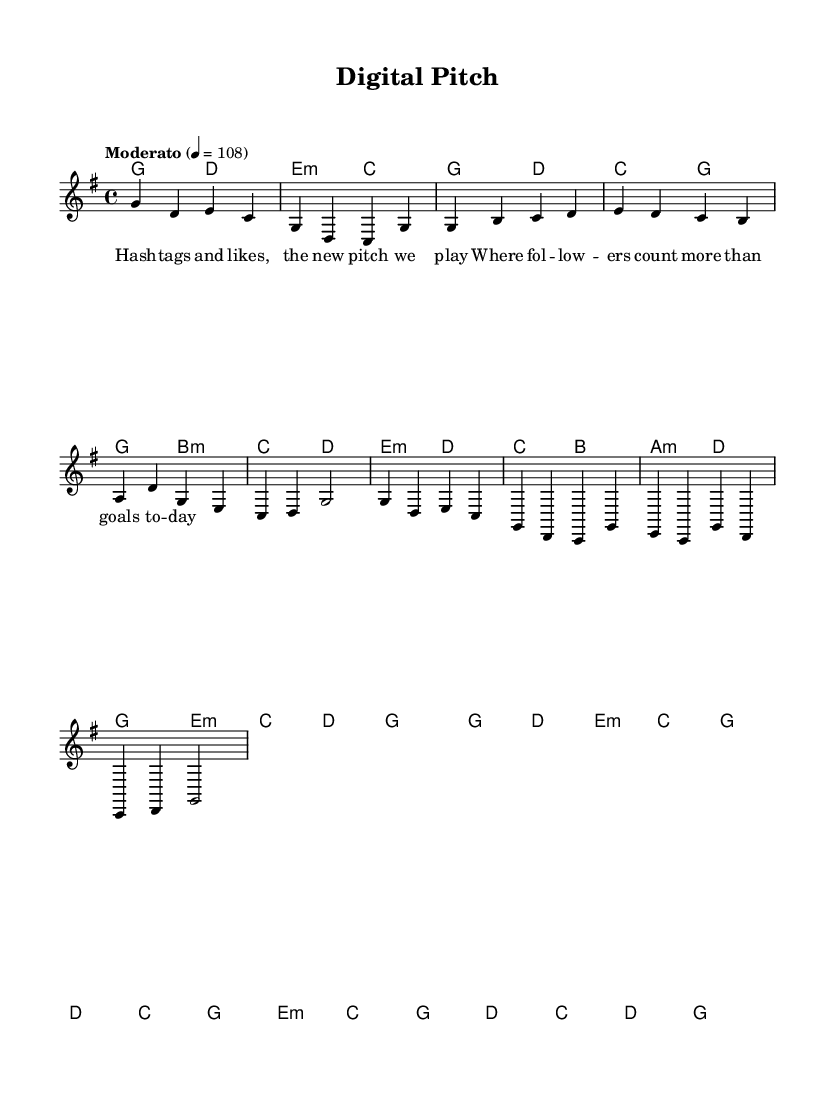What is the key signature of this music? The key signature is indicated at the beginning of the music score, showing one sharp for F sharp. This means the music is in G major.
Answer: G major What is the time signature of this piece? The time signature appears at the start of the score, showing 4 beats per measure, which is common in many music styles, indicating a 4/4 time signature.
Answer: 4/4 What is the tempo marking for this composition? The tempo marking is found in the header section of the score, where it specifies a moderate speed of 108 beats per minute.
Answer: Moderato, 108 How many measures are in the verse section? By counting the individual segments of the verse in the melody and harmonies, there are a total of 8 measures in the verse section.
Answer: 8 Which style does this piece represent? The title and the characteristics of the music, incorporating electronic elements and modern themes, indicate it belongs to the modern folk fusion genre.
Answer: Modern folk fusion What are the primary themes of the lyrics? The lyrics in the verse focus on social media's influence and its impact on how followers and likes have taken precedence over traditional sports achievements.
Answer: Social media's impact What is the relationship between melody and harmonies here? The melody is designed to complement the harmonies; for every note or chord in the melody, there is a corresponding harmony, establishing musical support and depth in the piece.
Answer: Complementary 